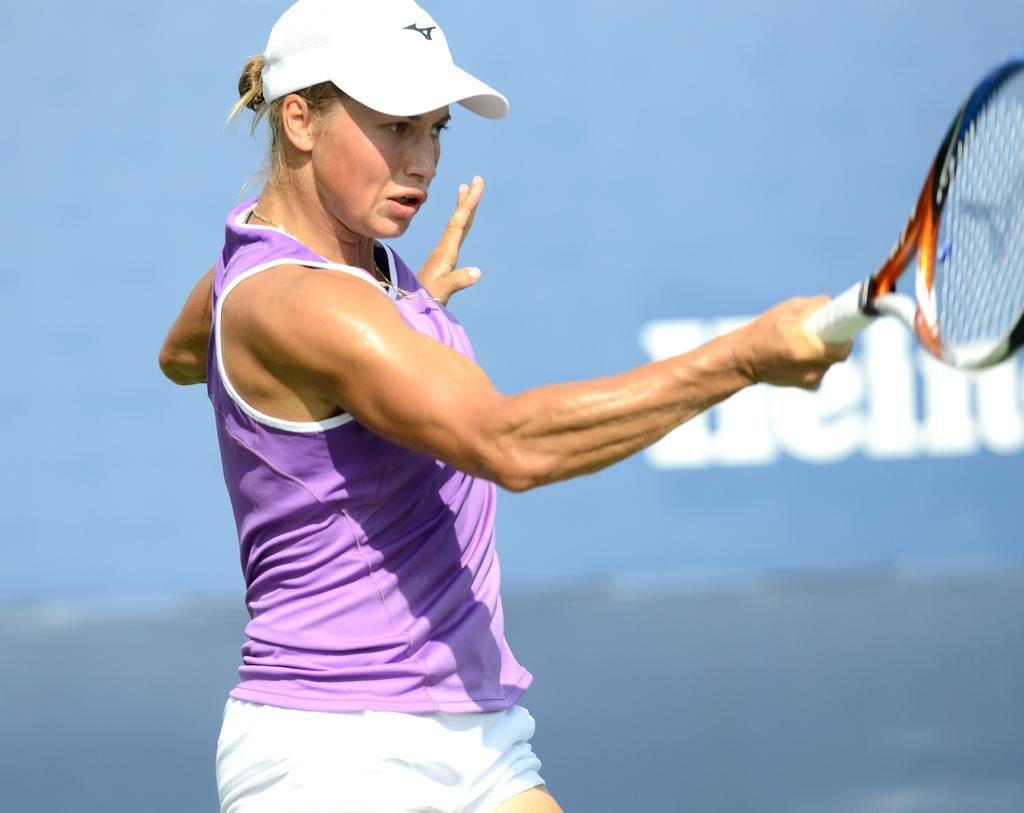Who is present in the image? There is a woman in the image. What is the woman wearing? The woman is wearing a sports uniform. What object is the woman holding? The woman is holding a tennis racket. What can be seen in the background of the image? There is a wall with text in the background of the image. We start by identifying the main subject of the image, which is the woman. Then, we describe her attire and the object she is holding, which are relevant to the sport of tennis. Finally, we mention the background detail, which provides context for the setting. Absurd Question/Answer: How many bikes are parked next to the woman in the image? There are no bikes present in the image. What type of button does the woman use to control her magic powers? The image does not depict any magic powers or buttons related to them. How many bikes are parked next to the woman in the image? There are no bikes present in the image. What type of button does the woman use to control her magic powers? The image does not depict any magic powers or buttons related to them. 